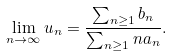<formula> <loc_0><loc_0><loc_500><loc_500>\lim _ { n \rightarrow \infty } u _ { n } = \frac { \sum _ { n \geq 1 } b _ { n } } { \sum _ { n \geq 1 } n a _ { n } } .</formula> 